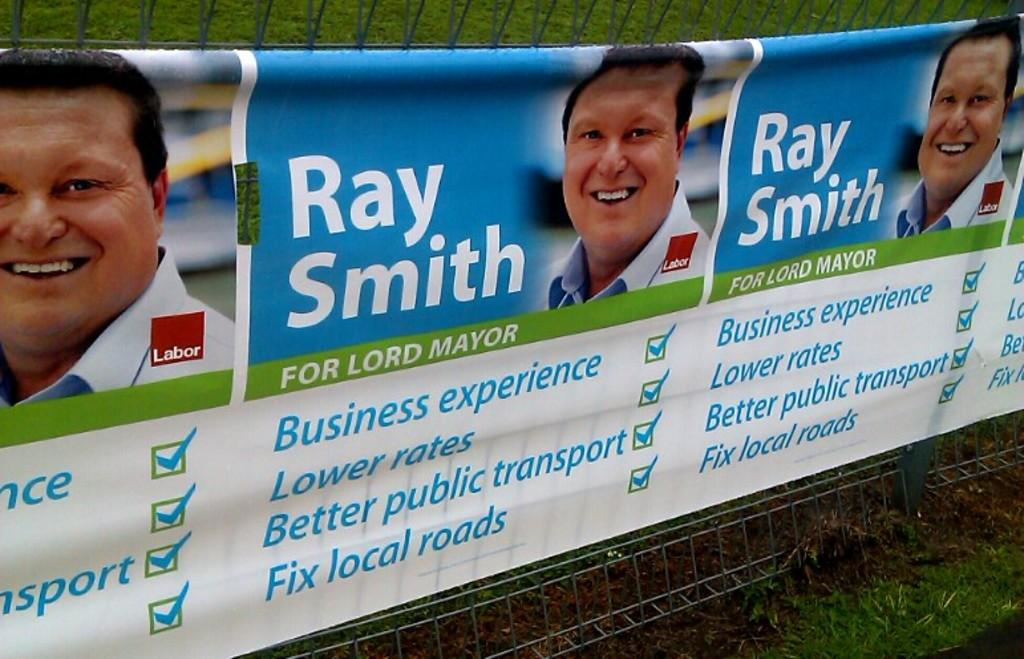What is located in the foreground of the image? There is a banner in the foreground of the image. Where is the banner positioned in the image? The banner is in the middle of the image. What is the material of the banner? There is a mesh associated with the banner. What type of vegetation is present on either side of the banner? There is grass on either side of the banner. What type of knowledge can be gained from observing the bears in the image? There are no bears present in the image, so no knowledge about bears can be gained from observing it. 